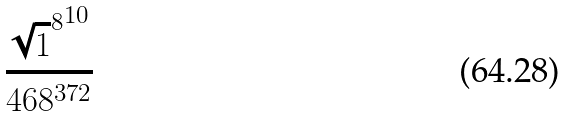<formula> <loc_0><loc_0><loc_500><loc_500>\frac { { \sqrt { 1 } ^ { 8 } } ^ { 1 0 } } { 4 6 8 ^ { 3 7 2 } }</formula> 